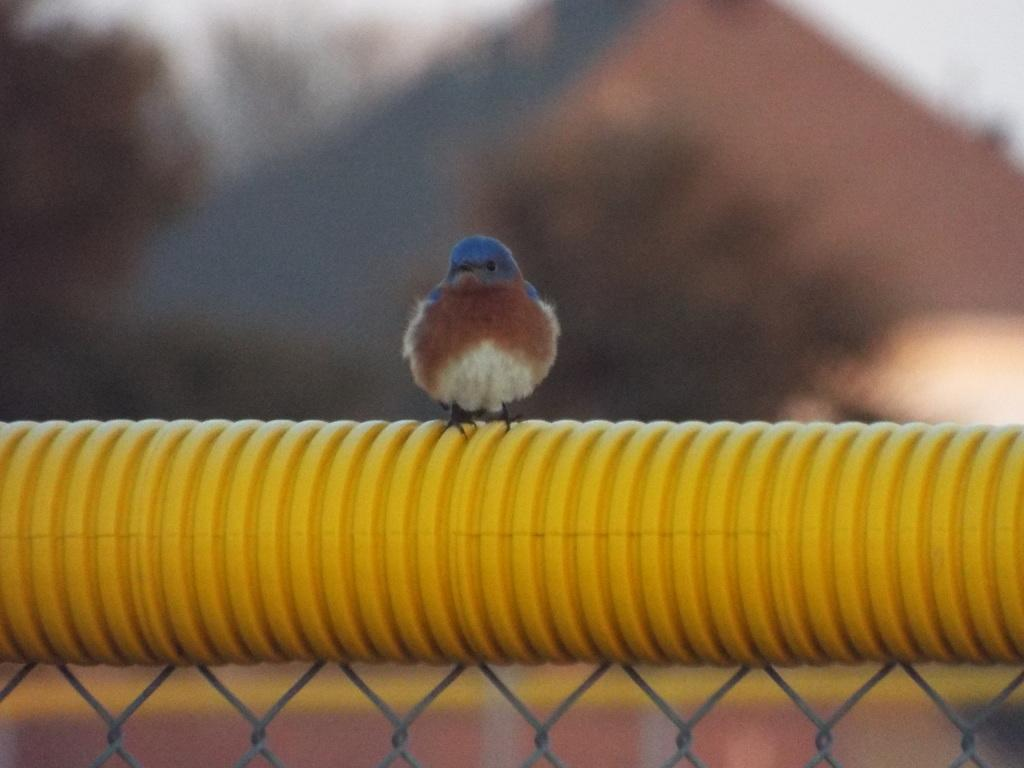What type of animal is in the image? There is a bird in the image. What is the bird sitting on? The bird is sitting on a yellow object. Can you describe the background of the image? The background of the image is blurred. What type of crook can be seen in the image? There is no crook present in the image; it features a bird sitting on a yellow object. What shape is the alley in the image? There is no alley present in the image; it features a bird sitting on a yellow object with a blurred background. 